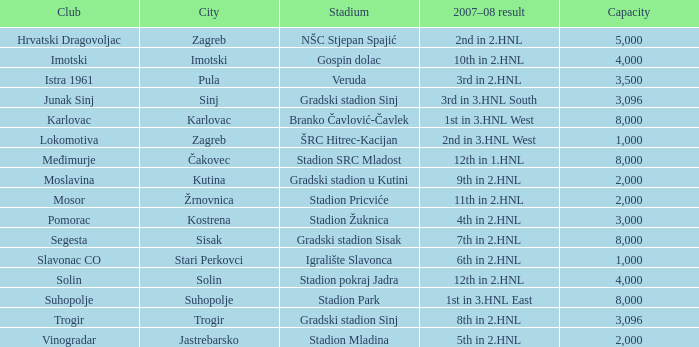Hnl as the outcome for the 2007-08 season? Gradski stadion u Kutini. 